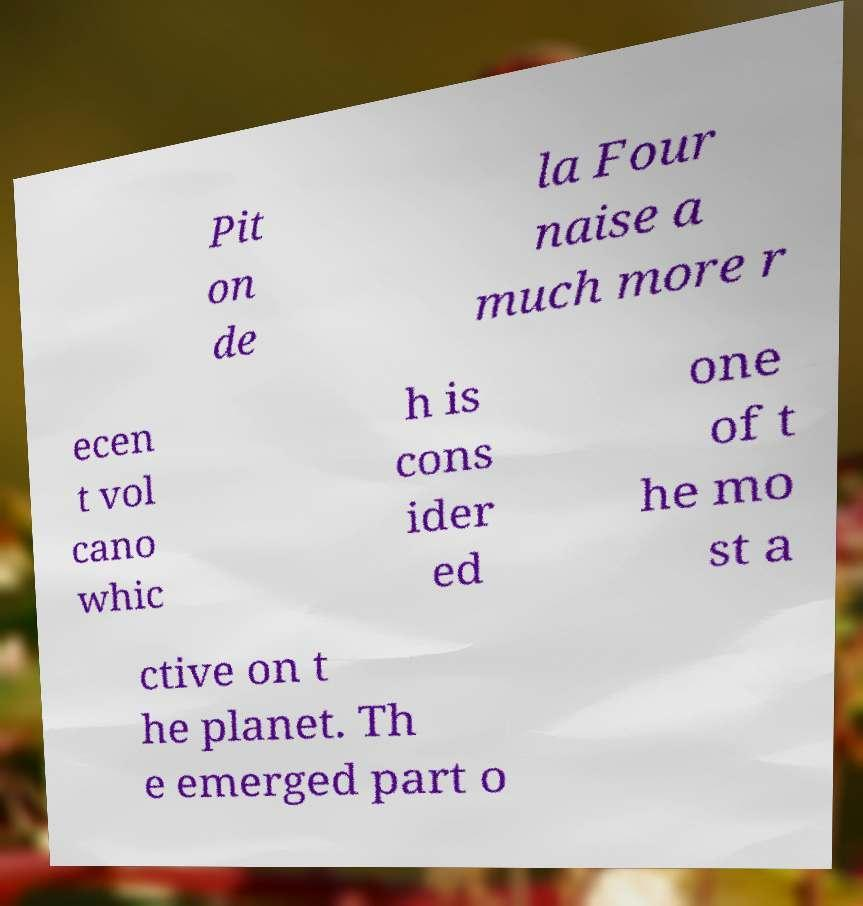Could you assist in decoding the text presented in this image and type it out clearly? Pit on de la Four naise a much more r ecen t vol cano whic h is cons ider ed one of t he mo st a ctive on t he planet. Th e emerged part o 